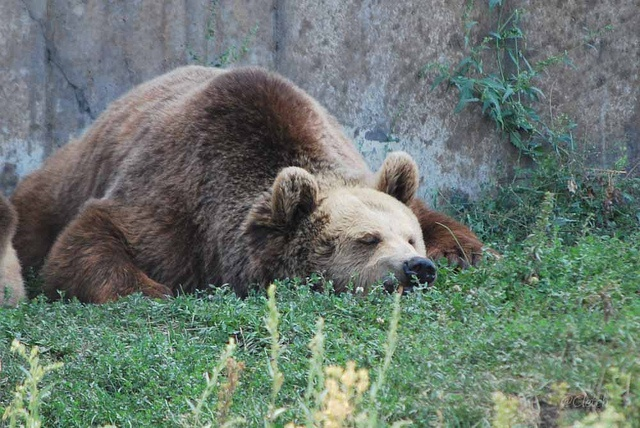Describe the objects in this image and their specific colors. I can see bear in gray, black, and darkgray tones and bear in gray, darkgray, and black tones in this image. 